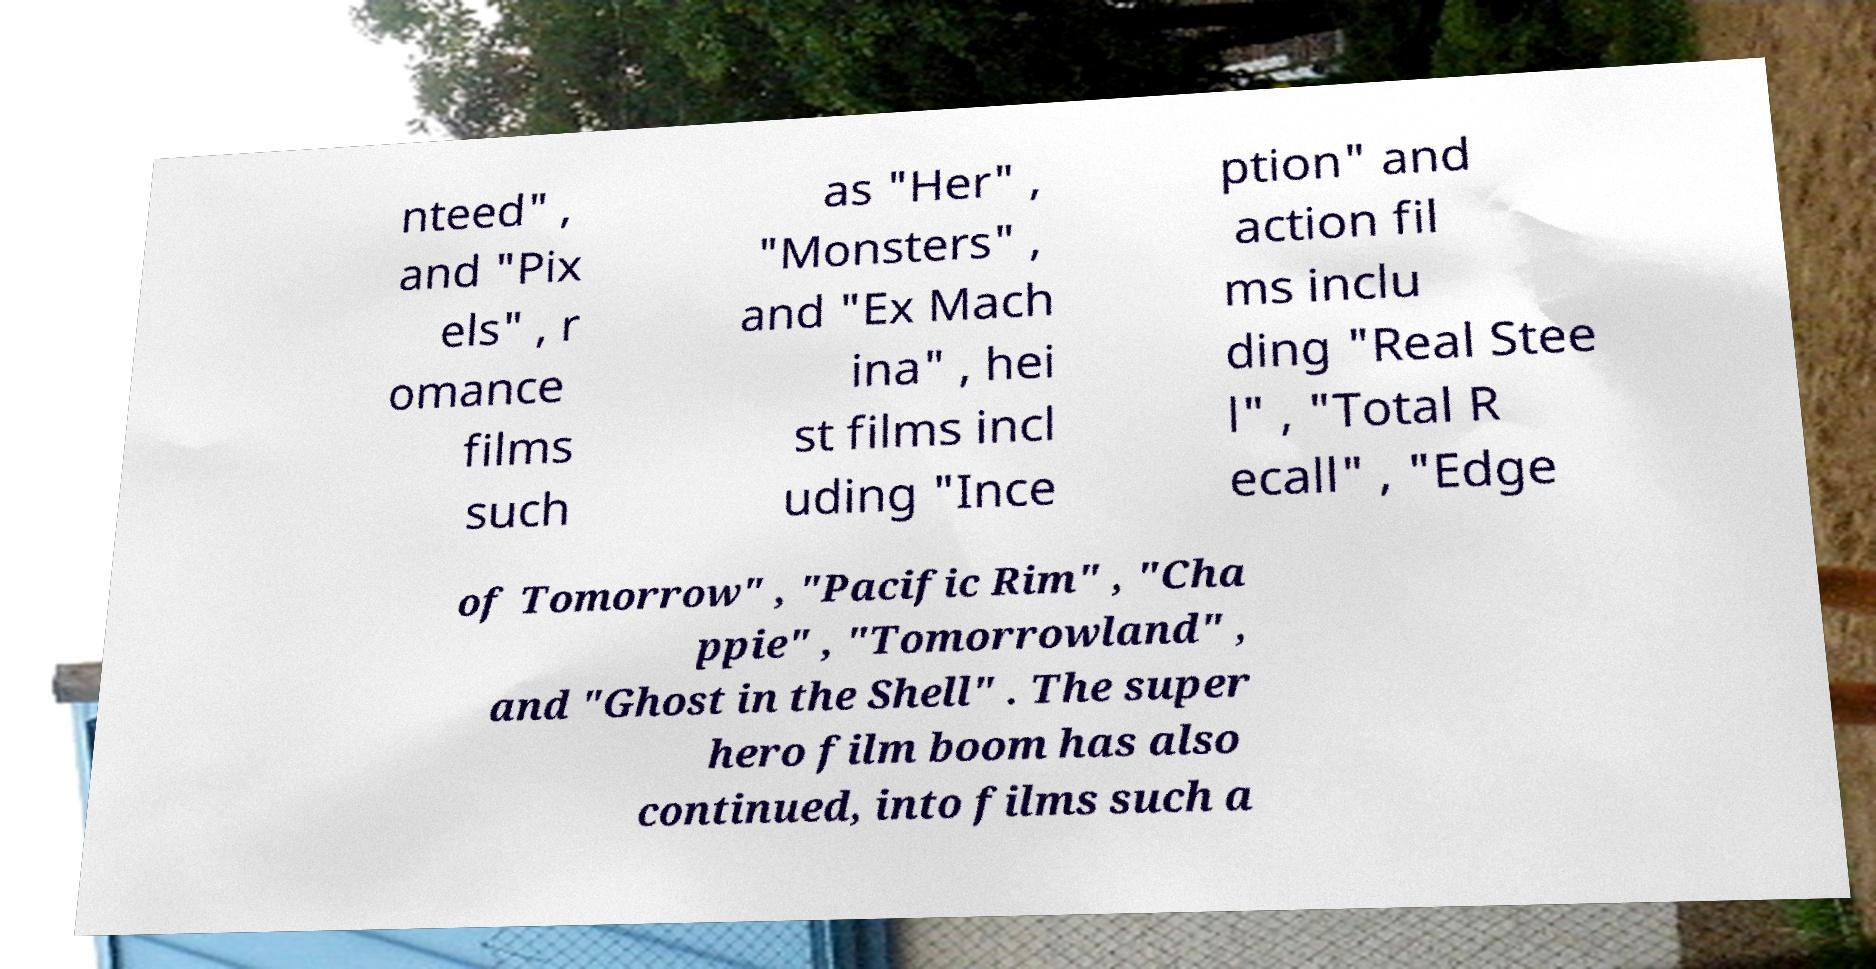Could you extract and type out the text from this image? nteed" , and "Pix els" , r omance films such as "Her" , "Monsters" , and "Ex Mach ina" , hei st films incl uding "Ince ption" and action fil ms inclu ding "Real Stee l" , "Total R ecall" , "Edge of Tomorrow" , "Pacific Rim" , "Cha ppie" , "Tomorrowland" , and "Ghost in the Shell" . The super hero film boom has also continued, into films such a 